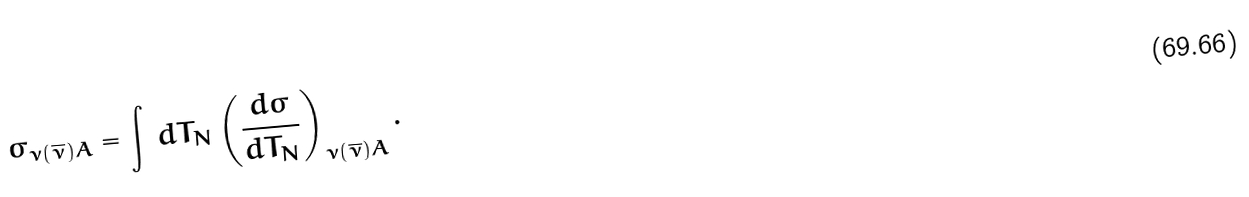Convert formula to latex. <formula><loc_0><loc_0><loc_500><loc_500>\sigma _ { \nu ( \overline { \nu } ) A } = \int \, d T _ { N } \left ( \frac { d \sigma } { d T _ { N } } \right ) _ { \nu ( \overline { \nu } ) A } .</formula> 